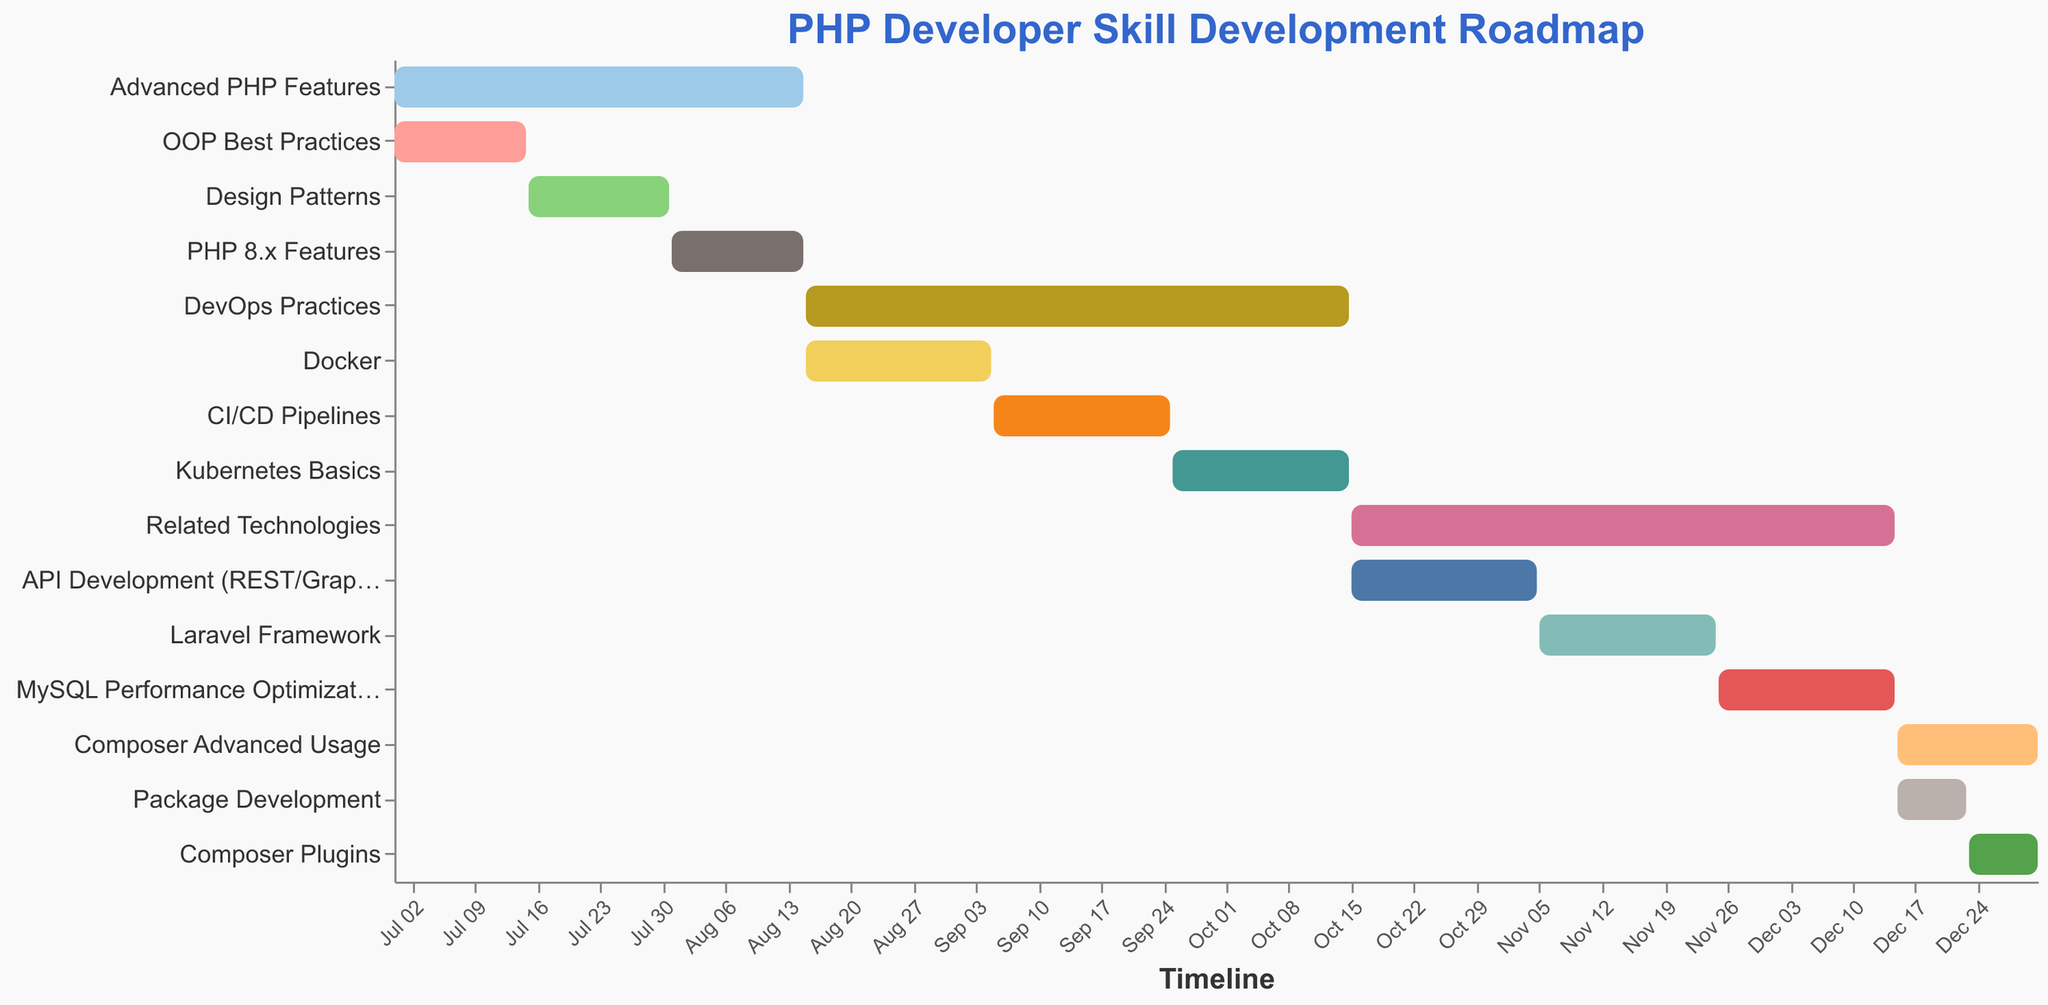What is the title of the figure? The title is positioned at the top of the figure in a larger font size. It says "PHP Developer Skill Development Roadmap".
Answer: PHP Developer Skill Development Roadmap Which task has the longest duration? By examining the bar lengths and the given durations, "DevOps Practices" and "Related Technologies" both have the longest duration of 61 days.
Answer: DevOps Practices and Related Technologies When does the learning for "Docker" start? The start date for each task is listed alongside the task. "Docker" starts on 2023-08-16.
Answer: 2023-08-16 How many days in total are dedicated to learning Composer advanced usage and plugins? "Composer Advanced Usage" lasts for 16 days and "Composer Plugins" for 8 days. Adding these durations: 16 + 8 = 24 days.
Answer: 24 days What is the average duration (in days) for all tasks? Sum up all durations and then divide by the number of tasks. The durations are: 46, 15, 16, 15, 61, 21, 20, 20, 61, 21, 20, 20, 16, 8, and 8. Sum: 368 days. There are 15 tasks. Average = 368/15 = 24.53 days.
Answer: 24.53 days Which has a longer duration, learning "Kubernetes Basics" or "CI/CD Pipelines"? Each task's duration is shown. "Kubernetes Basics" lasts for 20 days, and "CI/CD Pipelines" also lasts for 20 days. They have equal durations.
Answer: They have equal durations Between "Design Patterns" and "PHP 8.x Features", which one has a shorter learning period? "Design Patterns" lasts for 16 days, and "PHP 8.x Features" lasts for 15 days.
Answer: PHP 8.x Features Which tasks overlap with the learning period of "CI/CD Pipelines"? Look for tasks that have a start or end date between 2023-09-06 and 2023-09-25. "DevOps Practices" and "Docker" overlap with "CI/CD Pipelines".
Answer: DevOps Practices and Docker What is the end date for "MySQL Performance Optimization"? "MySQL Performance Optimization" has an end date listed as 2023-12-15.
Answer: 2023-12-15 